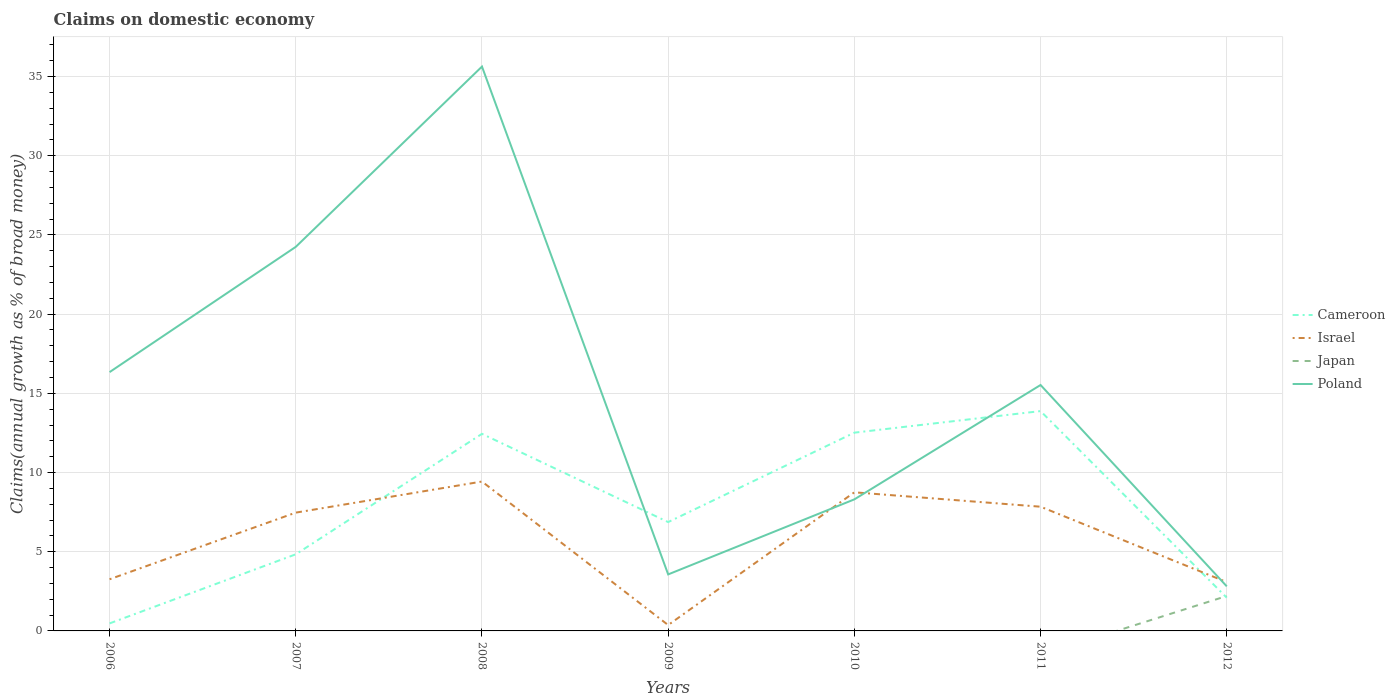How many different coloured lines are there?
Keep it short and to the point. 4. Is the number of lines equal to the number of legend labels?
Your response must be concise. No. Across all years, what is the maximum percentage of broad money claimed on domestic economy in Cameroon?
Keep it short and to the point. 0.47. What is the total percentage of broad money claimed on domestic economy in Cameroon in the graph?
Keep it short and to the point. -4.36. What is the difference between the highest and the second highest percentage of broad money claimed on domestic economy in Poland?
Your answer should be very brief. 32.82. Is the percentage of broad money claimed on domestic economy in Japan strictly greater than the percentage of broad money claimed on domestic economy in Poland over the years?
Your answer should be compact. Yes. Are the values on the major ticks of Y-axis written in scientific E-notation?
Your answer should be compact. No. Where does the legend appear in the graph?
Give a very brief answer. Center right. How many legend labels are there?
Provide a succinct answer. 4. What is the title of the graph?
Ensure brevity in your answer.  Claims on domestic economy. Does "Turks and Caicos Islands" appear as one of the legend labels in the graph?
Your answer should be compact. No. What is the label or title of the Y-axis?
Give a very brief answer. Claims(annual growth as % of broad money). What is the Claims(annual growth as % of broad money) in Cameroon in 2006?
Provide a succinct answer. 0.47. What is the Claims(annual growth as % of broad money) of Israel in 2006?
Make the answer very short. 3.26. What is the Claims(annual growth as % of broad money) in Poland in 2006?
Your answer should be very brief. 16.34. What is the Claims(annual growth as % of broad money) in Cameroon in 2007?
Give a very brief answer. 4.84. What is the Claims(annual growth as % of broad money) of Israel in 2007?
Your answer should be very brief. 7.47. What is the Claims(annual growth as % of broad money) in Japan in 2007?
Offer a terse response. 0. What is the Claims(annual growth as % of broad money) of Poland in 2007?
Make the answer very short. 24.25. What is the Claims(annual growth as % of broad money) of Cameroon in 2008?
Keep it short and to the point. 12.44. What is the Claims(annual growth as % of broad money) in Israel in 2008?
Offer a very short reply. 9.43. What is the Claims(annual growth as % of broad money) of Poland in 2008?
Make the answer very short. 35.63. What is the Claims(annual growth as % of broad money) in Cameroon in 2009?
Your response must be concise. 6.87. What is the Claims(annual growth as % of broad money) of Israel in 2009?
Offer a very short reply. 0.37. What is the Claims(annual growth as % of broad money) of Japan in 2009?
Your response must be concise. 0. What is the Claims(annual growth as % of broad money) of Poland in 2009?
Provide a short and direct response. 3.57. What is the Claims(annual growth as % of broad money) of Cameroon in 2010?
Your response must be concise. 12.52. What is the Claims(annual growth as % of broad money) in Israel in 2010?
Make the answer very short. 8.75. What is the Claims(annual growth as % of broad money) of Japan in 2010?
Give a very brief answer. 0. What is the Claims(annual growth as % of broad money) in Poland in 2010?
Provide a succinct answer. 8.31. What is the Claims(annual growth as % of broad money) in Cameroon in 2011?
Provide a succinct answer. 13.88. What is the Claims(annual growth as % of broad money) of Israel in 2011?
Ensure brevity in your answer.  7.84. What is the Claims(annual growth as % of broad money) of Poland in 2011?
Your answer should be very brief. 15.53. What is the Claims(annual growth as % of broad money) in Cameroon in 2012?
Make the answer very short. 2.1. What is the Claims(annual growth as % of broad money) of Israel in 2012?
Your answer should be compact. 3.08. What is the Claims(annual growth as % of broad money) in Japan in 2012?
Keep it short and to the point. 2.21. What is the Claims(annual growth as % of broad money) of Poland in 2012?
Provide a short and direct response. 2.81. Across all years, what is the maximum Claims(annual growth as % of broad money) in Cameroon?
Your response must be concise. 13.88. Across all years, what is the maximum Claims(annual growth as % of broad money) of Israel?
Provide a short and direct response. 9.43. Across all years, what is the maximum Claims(annual growth as % of broad money) in Japan?
Offer a very short reply. 2.21. Across all years, what is the maximum Claims(annual growth as % of broad money) in Poland?
Make the answer very short. 35.63. Across all years, what is the minimum Claims(annual growth as % of broad money) in Cameroon?
Your answer should be very brief. 0.47. Across all years, what is the minimum Claims(annual growth as % of broad money) of Israel?
Provide a short and direct response. 0.37. Across all years, what is the minimum Claims(annual growth as % of broad money) of Japan?
Your response must be concise. 0. Across all years, what is the minimum Claims(annual growth as % of broad money) of Poland?
Provide a succinct answer. 2.81. What is the total Claims(annual growth as % of broad money) of Cameroon in the graph?
Your answer should be very brief. 53.12. What is the total Claims(annual growth as % of broad money) of Israel in the graph?
Make the answer very short. 40.21. What is the total Claims(annual growth as % of broad money) in Japan in the graph?
Provide a short and direct response. 2.21. What is the total Claims(annual growth as % of broad money) of Poland in the graph?
Ensure brevity in your answer.  106.43. What is the difference between the Claims(annual growth as % of broad money) in Cameroon in 2006 and that in 2007?
Give a very brief answer. -4.36. What is the difference between the Claims(annual growth as % of broad money) in Israel in 2006 and that in 2007?
Offer a very short reply. -4.21. What is the difference between the Claims(annual growth as % of broad money) in Poland in 2006 and that in 2007?
Provide a succinct answer. -7.91. What is the difference between the Claims(annual growth as % of broad money) of Cameroon in 2006 and that in 2008?
Your response must be concise. -11.97. What is the difference between the Claims(annual growth as % of broad money) in Israel in 2006 and that in 2008?
Provide a succinct answer. -6.17. What is the difference between the Claims(annual growth as % of broad money) of Poland in 2006 and that in 2008?
Give a very brief answer. -19.29. What is the difference between the Claims(annual growth as % of broad money) of Cameroon in 2006 and that in 2009?
Keep it short and to the point. -6.4. What is the difference between the Claims(annual growth as % of broad money) of Israel in 2006 and that in 2009?
Your answer should be compact. 2.89. What is the difference between the Claims(annual growth as % of broad money) of Poland in 2006 and that in 2009?
Ensure brevity in your answer.  12.77. What is the difference between the Claims(annual growth as % of broad money) of Cameroon in 2006 and that in 2010?
Your answer should be compact. -12.04. What is the difference between the Claims(annual growth as % of broad money) in Israel in 2006 and that in 2010?
Give a very brief answer. -5.49. What is the difference between the Claims(annual growth as % of broad money) in Poland in 2006 and that in 2010?
Offer a terse response. 8.03. What is the difference between the Claims(annual growth as % of broad money) of Cameroon in 2006 and that in 2011?
Offer a terse response. -13.4. What is the difference between the Claims(annual growth as % of broad money) of Israel in 2006 and that in 2011?
Your answer should be very brief. -4.58. What is the difference between the Claims(annual growth as % of broad money) in Poland in 2006 and that in 2011?
Your answer should be very brief. 0.81. What is the difference between the Claims(annual growth as % of broad money) in Cameroon in 2006 and that in 2012?
Your response must be concise. -1.62. What is the difference between the Claims(annual growth as % of broad money) of Israel in 2006 and that in 2012?
Keep it short and to the point. 0.18. What is the difference between the Claims(annual growth as % of broad money) of Poland in 2006 and that in 2012?
Ensure brevity in your answer.  13.52. What is the difference between the Claims(annual growth as % of broad money) of Cameroon in 2007 and that in 2008?
Provide a succinct answer. -7.6. What is the difference between the Claims(annual growth as % of broad money) of Israel in 2007 and that in 2008?
Your answer should be very brief. -1.96. What is the difference between the Claims(annual growth as % of broad money) in Poland in 2007 and that in 2008?
Make the answer very short. -11.38. What is the difference between the Claims(annual growth as % of broad money) in Cameroon in 2007 and that in 2009?
Make the answer very short. -2.04. What is the difference between the Claims(annual growth as % of broad money) of Israel in 2007 and that in 2009?
Provide a succinct answer. 7.1. What is the difference between the Claims(annual growth as % of broad money) in Poland in 2007 and that in 2009?
Give a very brief answer. 20.68. What is the difference between the Claims(annual growth as % of broad money) of Cameroon in 2007 and that in 2010?
Give a very brief answer. -7.68. What is the difference between the Claims(annual growth as % of broad money) in Israel in 2007 and that in 2010?
Your response must be concise. -1.28. What is the difference between the Claims(annual growth as % of broad money) in Poland in 2007 and that in 2010?
Provide a succinct answer. 15.94. What is the difference between the Claims(annual growth as % of broad money) of Cameroon in 2007 and that in 2011?
Offer a terse response. -9.04. What is the difference between the Claims(annual growth as % of broad money) of Israel in 2007 and that in 2011?
Give a very brief answer. -0.37. What is the difference between the Claims(annual growth as % of broad money) in Poland in 2007 and that in 2011?
Give a very brief answer. 8.72. What is the difference between the Claims(annual growth as % of broad money) in Cameroon in 2007 and that in 2012?
Offer a terse response. 2.74. What is the difference between the Claims(annual growth as % of broad money) in Israel in 2007 and that in 2012?
Make the answer very short. 4.39. What is the difference between the Claims(annual growth as % of broad money) in Poland in 2007 and that in 2012?
Your answer should be very brief. 21.43. What is the difference between the Claims(annual growth as % of broad money) of Cameroon in 2008 and that in 2009?
Provide a succinct answer. 5.57. What is the difference between the Claims(annual growth as % of broad money) in Israel in 2008 and that in 2009?
Make the answer very short. 9.06. What is the difference between the Claims(annual growth as % of broad money) in Poland in 2008 and that in 2009?
Your answer should be very brief. 32.06. What is the difference between the Claims(annual growth as % of broad money) in Cameroon in 2008 and that in 2010?
Your answer should be compact. -0.08. What is the difference between the Claims(annual growth as % of broad money) of Israel in 2008 and that in 2010?
Provide a succinct answer. 0.68. What is the difference between the Claims(annual growth as % of broad money) in Poland in 2008 and that in 2010?
Your answer should be very brief. 27.33. What is the difference between the Claims(annual growth as % of broad money) of Cameroon in 2008 and that in 2011?
Provide a short and direct response. -1.44. What is the difference between the Claims(annual growth as % of broad money) of Israel in 2008 and that in 2011?
Provide a short and direct response. 1.59. What is the difference between the Claims(annual growth as % of broad money) in Poland in 2008 and that in 2011?
Give a very brief answer. 20.1. What is the difference between the Claims(annual growth as % of broad money) of Cameroon in 2008 and that in 2012?
Your answer should be very brief. 10.35. What is the difference between the Claims(annual growth as % of broad money) in Israel in 2008 and that in 2012?
Offer a very short reply. 6.35. What is the difference between the Claims(annual growth as % of broad money) of Poland in 2008 and that in 2012?
Offer a very short reply. 32.82. What is the difference between the Claims(annual growth as % of broad money) in Cameroon in 2009 and that in 2010?
Provide a short and direct response. -5.64. What is the difference between the Claims(annual growth as % of broad money) in Israel in 2009 and that in 2010?
Your answer should be compact. -8.38. What is the difference between the Claims(annual growth as % of broad money) in Poland in 2009 and that in 2010?
Ensure brevity in your answer.  -4.74. What is the difference between the Claims(annual growth as % of broad money) in Cameroon in 2009 and that in 2011?
Provide a short and direct response. -7.01. What is the difference between the Claims(annual growth as % of broad money) in Israel in 2009 and that in 2011?
Your response must be concise. -7.47. What is the difference between the Claims(annual growth as % of broad money) of Poland in 2009 and that in 2011?
Provide a succinct answer. -11.96. What is the difference between the Claims(annual growth as % of broad money) of Cameroon in 2009 and that in 2012?
Ensure brevity in your answer.  4.78. What is the difference between the Claims(annual growth as % of broad money) of Israel in 2009 and that in 2012?
Provide a succinct answer. -2.71. What is the difference between the Claims(annual growth as % of broad money) in Poland in 2009 and that in 2012?
Provide a short and direct response. 0.75. What is the difference between the Claims(annual growth as % of broad money) of Cameroon in 2010 and that in 2011?
Your answer should be very brief. -1.36. What is the difference between the Claims(annual growth as % of broad money) of Israel in 2010 and that in 2011?
Keep it short and to the point. 0.91. What is the difference between the Claims(annual growth as % of broad money) in Poland in 2010 and that in 2011?
Make the answer very short. -7.22. What is the difference between the Claims(annual growth as % of broad money) in Cameroon in 2010 and that in 2012?
Offer a very short reply. 10.42. What is the difference between the Claims(annual growth as % of broad money) in Israel in 2010 and that in 2012?
Offer a very short reply. 5.67. What is the difference between the Claims(annual growth as % of broad money) in Poland in 2010 and that in 2012?
Make the answer very short. 5.49. What is the difference between the Claims(annual growth as % of broad money) in Cameroon in 2011 and that in 2012?
Your answer should be very brief. 11.78. What is the difference between the Claims(annual growth as % of broad money) in Israel in 2011 and that in 2012?
Your response must be concise. 4.76. What is the difference between the Claims(annual growth as % of broad money) in Poland in 2011 and that in 2012?
Give a very brief answer. 12.71. What is the difference between the Claims(annual growth as % of broad money) of Cameroon in 2006 and the Claims(annual growth as % of broad money) of Israel in 2007?
Offer a very short reply. -7. What is the difference between the Claims(annual growth as % of broad money) in Cameroon in 2006 and the Claims(annual growth as % of broad money) in Poland in 2007?
Your answer should be very brief. -23.77. What is the difference between the Claims(annual growth as % of broad money) of Israel in 2006 and the Claims(annual growth as % of broad money) of Poland in 2007?
Your response must be concise. -20.99. What is the difference between the Claims(annual growth as % of broad money) in Cameroon in 2006 and the Claims(annual growth as % of broad money) in Israel in 2008?
Ensure brevity in your answer.  -8.96. What is the difference between the Claims(annual growth as % of broad money) in Cameroon in 2006 and the Claims(annual growth as % of broad money) in Poland in 2008?
Ensure brevity in your answer.  -35.16. What is the difference between the Claims(annual growth as % of broad money) of Israel in 2006 and the Claims(annual growth as % of broad money) of Poland in 2008?
Keep it short and to the point. -32.37. What is the difference between the Claims(annual growth as % of broad money) of Cameroon in 2006 and the Claims(annual growth as % of broad money) of Israel in 2009?
Offer a very short reply. 0.1. What is the difference between the Claims(annual growth as % of broad money) in Cameroon in 2006 and the Claims(annual growth as % of broad money) in Poland in 2009?
Make the answer very short. -3.09. What is the difference between the Claims(annual growth as % of broad money) of Israel in 2006 and the Claims(annual growth as % of broad money) of Poland in 2009?
Keep it short and to the point. -0.31. What is the difference between the Claims(annual growth as % of broad money) in Cameroon in 2006 and the Claims(annual growth as % of broad money) in Israel in 2010?
Your answer should be very brief. -8.28. What is the difference between the Claims(annual growth as % of broad money) of Cameroon in 2006 and the Claims(annual growth as % of broad money) of Poland in 2010?
Provide a succinct answer. -7.83. What is the difference between the Claims(annual growth as % of broad money) of Israel in 2006 and the Claims(annual growth as % of broad money) of Poland in 2010?
Offer a very short reply. -5.04. What is the difference between the Claims(annual growth as % of broad money) of Cameroon in 2006 and the Claims(annual growth as % of broad money) of Israel in 2011?
Provide a succinct answer. -7.37. What is the difference between the Claims(annual growth as % of broad money) in Cameroon in 2006 and the Claims(annual growth as % of broad money) in Poland in 2011?
Ensure brevity in your answer.  -15.05. What is the difference between the Claims(annual growth as % of broad money) in Israel in 2006 and the Claims(annual growth as % of broad money) in Poland in 2011?
Give a very brief answer. -12.27. What is the difference between the Claims(annual growth as % of broad money) in Cameroon in 2006 and the Claims(annual growth as % of broad money) in Israel in 2012?
Offer a very short reply. -2.61. What is the difference between the Claims(annual growth as % of broad money) in Cameroon in 2006 and the Claims(annual growth as % of broad money) in Japan in 2012?
Keep it short and to the point. -1.73. What is the difference between the Claims(annual growth as % of broad money) in Cameroon in 2006 and the Claims(annual growth as % of broad money) in Poland in 2012?
Provide a short and direct response. -2.34. What is the difference between the Claims(annual growth as % of broad money) in Israel in 2006 and the Claims(annual growth as % of broad money) in Japan in 2012?
Provide a short and direct response. 1.06. What is the difference between the Claims(annual growth as % of broad money) of Israel in 2006 and the Claims(annual growth as % of broad money) of Poland in 2012?
Offer a very short reply. 0.45. What is the difference between the Claims(annual growth as % of broad money) of Cameroon in 2007 and the Claims(annual growth as % of broad money) of Israel in 2008?
Offer a very short reply. -4.59. What is the difference between the Claims(annual growth as % of broad money) of Cameroon in 2007 and the Claims(annual growth as % of broad money) of Poland in 2008?
Give a very brief answer. -30.79. What is the difference between the Claims(annual growth as % of broad money) of Israel in 2007 and the Claims(annual growth as % of broad money) of Poland in 2008?
Your response must be concise. -28.16. What is the difference between the Claims(annual growth as % of broad money) in Cameroon in 2007 and the Claims(annual growth as % of broad money) in Israel in 2009?
Offer a very short reply. 4.47. What is the difference between the Claims(annual growth as % of broad money) of Cameroon in 2007 and the Claims(annual growth as % of broad money) of Poland in 2009?
Give a very brief answer. 1.27. What is the difference between the Claims(annual growth as % of broad money) of Israel in 2007 and the Claims(annual growth as % of broad money) of Poland in 2009?
Your response must be concise. 3.9. What is the difference between the Claims(annual growth as % of broad money) of Cameroon in 2007 and the Claims(annual growth as % of broad money) of Israel in 2010?
Offer a terse response. -3.91. What is the difference between the Claims(annual growth as % of broad money) in Cameroon in 2007 and the Claims(annual growth as % of broad money) in Poland in 2010?
Keep it short and to the point. -3.47. What is the difference between the Claims(annual growth as % of broad money) of Israel in 2007 and the Claims(annual growth as % of broad money) of Poland in 2010?
Ensure brevity in your answer.  -0.84. What is the difference between the Claims(annual growth as % of broad money) in Cameroon in 2007 and the Claims(annual growth as % of broad money) in Israel in 2011?
Offer a very short reply. -3. What is the difference between the Claims(annual growth as % of broad money) in Cameroon in 2007 and the Claims(annual growth as % of broad money) in Poland in 2011?
Ensure brevity in your answer.  -10.69. What is the difference between the Claims(annual growth as % of broad money) in Israel in 2007 and the Claims(annual growth as % of broad money) in Poland in 2011?
Offer a terse response. -8.06. What is the difference between the Claims(annual growth as % of broad money) of Cameroon in 2007 and the Claims(annual growth as % of broad money) of Israel in 2012?
Provide a short and direct response. 1.76. What is the difference between the Claims(annual growth as % of broad money) of Cameroon in 2007 and the Claims(annual growth as % of broad money) of Japan in 2012?
Make the answer very short. 2.63. What is the difference between the Claims(annual growth as % of broad money) in Cameroon in 2007 and the Claims(annual growth as % of broad money) in Poland in 2012?
Offer a very short reply. 2.02. What is the difference between the Claims(annual growth as % of broad money) in Israel in 2007 and the Claims(annual growth as % of broad money) in Japan in 2012?
Your answer should be compact. 5.26. What is the difference between the Claims(annual growth as % of broad money) in Israel in 2007 and the Claims(annual growth as % of broad money) in Poland in 2012?
Give a very brief answer. 4.65. What is the difference between the Claims(annual growth as % of broad money) of Cameroon in 2008 and the Claims(annual growth as % of broad money) of Israel in 2009?
Your response must be concise. 12.07. What is the difference between the Claims(annual growth as % of broad money) in Cameroon in 2008 and the Claims(annual growth as % of broad money) in Poland in 2009?
Provide a short and direct response. 8.87. What is the difference between the Claims(annual growth as % of broad money) of Israel in 2008 and the Claims(annual growth as % of broad money) of Poland in 2009?
Offer a very short reply. 5.86. What is the difference between the Claims(annual growth as % of broad money) in Cameroon in 2008 and the Claims(annual growth as % of broad money) in Israel in 2010?
Your answer should be compact. 3.69. What is the difference between the Claims(annual growth as % of broad money) in Cameroon in 2008 and the Claims(annual growth as % of broad money) in Poland in 2010?
Provide a short and direct response. 4.14. What is the difference between the Claims(annual growth as % of broad money) in Israel in 2008 and the Claims(annual growth as % of broad money) in Poland in 2010?
Make the answer very short. 1.13. What is the difference between the Claims(annual growth as % of broad money) of Cameroon in 2008 and the Claims(annual growth as % of broad money) of Israel in 2011?
Make the answer very short. 4.6. What is the difference between the Claims(annual growth as % of broad money) in Cameroon in 2008 and the Claims(annual growth as % of broad money) in Poland in 2011?
Provide a succinct answer. -3.08. What is the difference between the Claims(annual growth as % of broad money) in Israel in 2008 and the Claims(annual growth as % of broad money) in Poland in 2011?
Provide a short and direct response. -6.1. What is the difference between the Claims(annual growth as % of broad money) of Cameroon in 2008 and the Claims(annual growth as % of broad money) of Israel in 2012?
Your answer should be compact. 9.36. What is the difference between the Claims(annual growth as % of broad money) of Cameroon in 2008 and the Claims(annual growth as % of broad money) of Japan in 2012?
Your answer should be very brief. 10.24. What is the difference between the Claims(annual growth as % of broad money) of Cameroon in 2008 and the Claims(annual growth as % of broad money) of Poland in 2012?
Offer a terse response. 9.63. What is the difference between the Claims(annual growth as % of broad money) of Israel in 2008 and the Claims(annual growth as % of broad money) of Japan in 2012?
Ensure brevity in your answer.  7.23. What is the difference between the Claims(annual growth as % of broad money) in Israel in 2008 and the Claims(annual growth as % of broad money) in Poland in 2012?
Provide a succinct answer. 6.62. What is the difference between the Claims(annual growth as % of broad money) in Cameroon in 2009 and the Claims(annual growth as % of broad money) in Israel in 2010?
Provide a short and direct response. -1.88. What is the difference between the Claims(annual growth as % of broad money) of Cameroon in 2009 and the Claims(annual growth as % of broad money) of Poland in 2010?
Provide a short and direct response. -1.43. What is the difference between the Claims(annual growth as % of broad money) in Israel in 2009 and the Claims(annual growth as % of broad money) in Poland in 2010?
Keep it short and to the point. -7.93. What is the difference between the Claims(annual growth as % of broad money) of Cameroon in 2009 and the Claims(annual growth as % of broad money) of Israel in 2011?
Your answer should be very brief. -0.97. What is the difference between the Claims(annual growth as % of broad money) in Cameroon in 2009 and the Claims(annual growth as % of broad money) in Poland in 2011?
Keep it short and to the point. -8.65. What is the difference between the Claims(annual growth as % of broad money) in Israel in 2009 and the Claims(annual growth as % of broad money) in Poland in 2011?
Give a very brief answer. -15.16. What is the difference between the Claims(annual growth as % of broad money) of Cameroon in 2009 and the Claims(annual growth as % of broad money) of Israel in 2012?
Give a very brief answer. 3.79. What is the difference between the Claims(annual growth as % of broad money) in Cameroon in 2009 and the Claims(annual growth as % of broad money) in Japan in 2012?
Provide a short and direct response. 4.67. What is the difference between the Claims(annual growth as % of broad money) in Cameroon in 2009 and the Claims(annual growth as % of broad money) in Poland in 2012?
Give a very brief answer. 4.06. What is the difference between the Claims(annual growth as % of broad money) of Israel in 2009 and the Claims(annual growth as % of broad money) of Japan in 2012?
Provide a succinct answer. -1.83. What is the difference between the Claims(annual growth as % of broad money) of Israel in 2009 and the Claims(annual growth as % of broad money) of Poland in 2012?
Your answer should be compact. -2.44. What is the difference between the Claims(annual growth as % of broad money) of Cameroon in 2010 and the Claims(annual growth as % of broad money) of Israel in 2011?
Offer a very short reply. 4.68. What is the difference between the Claims(annual growth as % of broad money) in Cameroon in 2010 and the Claims(annual growth as % of broad money) in Poland in 2011?
Ensure brevity in your answer.  -3.01. What is the difference between the Claims(annual growth as % of broad money) of Israel in 2010 and the Claims(annual growth as % of broad money) of Poland in 2011?
Ensure brevity in your answer.  -6.78. What is the difference between the Claims(annual growth as % of broad money) in Cameroon in 2010 and the Claims(annual growth as % of broad money) in Israel in 2012?
Your response must be concise. 9.44. What is the difference between the Claims(annual growth as % of broad money) in Cameroon in 2010 and the Claims(annual growth as % of broad money) in Japan in 2012?
Keep it short and to the point. 10.31. What is the difference between the Claims(annual growth as % of broad money) in Cameroon in 2010 and the Claims(annual growth as % of broad money) in Poland in 2012?
Provide a succinct answer. 9.7. What is the difference between the Claims(annual growth as % of broad money) in Israel in 2010 and the Claims(annual growth as % of broad money) in Japan in 2012?
Give a very brief answer. 6.55. What is the difference between the Claims(annual growth as % of broad money) of Israel in 2010 and the Claims(annual growth as % of broad money) of Poland in 2012?
Provide a succinct answer. 5.94. What is the difference between the Claims(annual growth as % of broad money) in Cameroon in 2011 and the Claims(annual growth as % of broad money) in Israel in 2012?
Provide a succinct answer. 10.8. What is the difference between the Claims(annual growth as % of broad money) of Cameroon in 2011 and the Claims(annual growth as % of broad money) of Japan in 2012?
Offer a terse response. 11.67. What is the difference between the Claims(annual growth as % of broad money) in Cameroon in 2011 and the Claims(annual growth as % of broad money) in Poland in 2012?
Offer a very short reply. 11.06. What is the difference between the Claims(annual growth as % of broad money) in Israel in 2011 and the Claims(annual growth as % of broad money) in Japan in 2012?
Keep it short and to the point. 5.64. What is the difference between the Claims(annual growth as % of broad money) in Israel in 2011 and the Claims(annual growth as % of broad money) in Poland in 2012?
Keep it short and to the point. 5.03. What is the average Claims(annual growth as % of broad money) of Cameroon per year?
Your response must be concise. 7.59. What is the average Claims(annual growth as % of broad money) of Israel per year?
Provide a succinct answer. 5.74. What is the average Claims(annual growth as % of broad money) in Japan per year?
Offer a terse response. 0.32. What is the average Claims(annual growth as % of broad money) of Poland per year?
Your response must be concise. 15.2. In the year 2006, what is the difference between the Claims(annual growth as % of broad money) of Cameroon and Claims(annual growth as % of broad money) of Israel?
Offer a terse response. -2.79. In the year 2006, what is the difference between the Claims(annual growth as % of broad money) of Cameroon and Claims(annual growth as % of broad money) of Poland?
Your answer should be compact. -15.86. In the year 2006, what is the difference between the Claims(annual growth as % of broad money) of Israel and Claims(annual growth as % of broad money) of Poland?
Provide a short and direct response. -13.08. In the year 2007, what is the difference between the Claims(annual growth as % of broad money) of Cameroon and Claims(annual growth as % of broad money) of Israel?
Your answer should be very brief. -2.63. In the year 2007, what is the difference between the Claims(annual growth as % of broad money) of Cameroon and Claims(annual growth as % of broad money) of Poland?
Offer a very short reply. -19.41. In the year 2007, what is the difference between the Claims(annual growth as % of broad money) in Israel and Claims(annual growth as % of broad money) in Poland?
Offer a terse response. -16.78. In the year 2008, what is the difference between the Claims(annual growth as % of broad money) in Cameroon and Claims(annual growth as % of broad money) in Israel?
Your answer should be very brief. 3.01. In the year 2008, what is the difference between the Claims(annual growth as % of broad money) in Cameroon and Claims(annual growth as % of broad money) in Poland?
Ensure brevity in your answer.  -23.19. In the year 2008, what is the difference between the Claims(annual growth as % of broad money) of Israel and Claims(annual growth as % of broad money) of Poland?
Keep it short and to the point. -26.2. In the year 2009, what is the difference between the Claims(annual growth as % of broad money) in Cameroon and Claims(annual growth as % of broad money) in Israel?
Your answer should be compact. 6.5. In the year 2009, what is the difference between the Claims(annual growth as % of broad money) of Cameroon and Claims(annual growth as % of broad money) of Poland?
Offer a terse response. 3.3. In the year 2009, what is the difference between the Claims(annual growth as % of broad money) of Israel and Claims(annual growth as % of broad money) of Poland?
Give a very brief answer. -3.2. In the year 2010, what is the difference between the Claims(annual growth as % of broad money) in Cameroon and Claims(annual growth as % of broad money) in Israel?
Offer a terse response. 3.77. In the year 2010, what is the difference between the Claims(annual growth as % of broad money) in Cameroon and Claims(annual growth as % of broad money) in Poland?
Offer a very short reply. 4.21. In the year 2010, what is the difference between the Claims(annual growth as % of broad money) in Israel and Claims(annual growth as % of broad money) in Poland?
Your answer should be compact. 0.45. In the year 2011, what is the difference between the Claims(annual growth as % of broad money) of Cameroon and Claims(annual growth as % of broad money) of Israel?
Your answer should be compact. 6.04. In the year 2011, what is the difference between the Claims(annual growth as % of broad money) in Cameroon and Claims(annual growth as % of broad money) in Poland?
Your answer should be compact. -1.65. In the year 2011, what is the difference between the Claims(annual growth as % of broad money) of Israel and Claims(annual growth as % of broad money) of Poland?
Provide a succinct answer. -7.68. In the year 2012, what is the difference between the Claims(annual growth as % of broad money) of Cameroon and Claims(annual growth as % of broad money) of Israel?
Keep it short and to the point. -0.98. In the year 2012, what is the difference between the Claims(annual growth as % of broad money) in Cameroon and Claims(annual growth as % of broad money) in Japan?
Offer a terse response. -0.11. In the year 2012, what is the difference between the Claims(annual growth as % of broad money) of Cameroon and Claims(annual growth as % of broad money) of Poland?
Your answer should be very brief. -0.72. In the year 2012, what is the difference between the Claims(annual growth as % of broad money) in Israel and Claims(annual growth as % of broad money) in Japan?
Your answer should be compact. 0.88. In the year 2012, what is the difference between the Claims(annual growth as % of broad money) of Israel and Claims(annual growth as % of broad money) of Poland?
Keep it short and to the point. 0.27. In the year 2012, what is the difference between the Claims(annual growth as % of broad money) in Japan and Claims(annual growth as % of broad money) in Poland?
Your answer should be very brief. -0.61. What is the ratio of the Claims(annual growth as % of broad money) in Cameroon in 2006 to that in 2007?
Provide a short and direct response. 0.1. What is the ratio of the Claims(annual growth as % of broad money) in Israel in 2006 to that in 2007?
Give a very brief answer. 0.44. What is the ratio of the Claims(annual growth as % of broad money) of Poland in 2006 to that in 2007?
Provide a succinct answer. 0.67. What is the ratio of the Claims(annual growth as % of broad money) in Cameroon in 2006 to that in 2008?
Your answer should be compact. 0.04. What is the ratio of the Claims(annual growth as % of broad money) in Israel in 2006 to that in 2008?
Ensure brevity in your answer.  0.35. What is the ratio of the Claims(annual growth as % of broad money) in Poland in 2006 to that in 2008?
Provide a succinct answer. 0.46. What is the ratio of the Claims(annual growth as % of broad money) in Cameroon in 2006 to that in 2009?
Your answer should be very brief. 0.07. What is the ratio of the Claims(annual growth as % of broad money) in Israel in 2006 to that in 2009?
Offer a very short reply. 8.79. What is the ratio of the Claims(annual growth as % of broad money) in Poland in 2006 to that in 2009?
Keep it short and to the point. 4.58. What is the ratio of the Claims(annual growth as % of broad money) of Cameroon in 2006 to that in 2010?
Your answer should be very brief. 0.04. What is the ratio of the Claims(annual growth as % of broad money) of Israel in 2006 to that in 2010?
Ensure brevity in your answer.  0.37. What is the ratio of the Claims(annual growth as % of broad money) in Poland in 2006 to that in 2010?
Make the answer very short. 1.97. What is the ratio of the Claims(annual growth as % of broad money) of Cameroon in 2006 to that in 2011?
Your response must be concise. 0.03. What is the ratio of the Claims(annual growth as % of broad money) in Israel in 2006 to that in 2011?
Provide a short and direct response. 0.42. What is the ratio of the Claims(annual growth as % of broad money) of Poland in 2006 to that in 2011?
Offer a terse response. 1.05. What is the ratio of the Claims(annual growth as % of broad money) of Cameroon in 2006 to that in 2012?
Keep it short and to the point. 0.23. What is the ratio of the Claims(annual growth as % of broad money) in Israel in 2006 to that in 2012?
Keep it short and to the point. 1.06. What is the ratio of the Claims(annual growth as % of broad money) of Poland in 2006 to that in 2012?
Your answer should be very brief. 5.81. What is the ratio of the Claims(annual growth as % of broad money) of Cameroon in 2007 to that in 2008?
Give a very brief answer. 0.39. What is the ratio of the Claims(annual growth as % of broad money) in Israel in 2007 to that in 2008?
Offer a terse response. 0.79. What is the ratio of the Claims(annual growth as % of broad money) of Poland in 2007 to that in 2008?
Keep it short and to the point. 0.68. What is the ratio of the Claims(annual growth as % of broad money) in Cameroon in 2007 to that in 2009?
Your answer should be compact. 0.7. What is the ratio of the Claims(annual growth as % of broad money) in Israel in 2007 to that in 2009?
Give a very brief answer. 20.14. What is the ratio of the Claims(annual growth as % of broad money) in Poland in 2007 to that in 2009?
Offer a very short reply. 6.8. What is the ratio of the Claims(annual growth as % of broad money) in Cameroon in 2007 to that in 2010?
Give a very brief answer. 0.39. What is the ratio of the Claims(annual growth as % of broad money) of Israel in 2007 to that in 2010?
Your answer should be compact. 0.85. What is the ratio of the Claims(annual growth as % of broad money) in Poland in 2007 to that in 2010?
Make the answer very short. 2.92. What is the ratio of the Claims(annual growth as % of broad money) of Cameroon in 2007 to that in 2011?
Provide a succinct answer. 0.35. What is the ratio of the Claims(annual growth as % of broad money) in Israel in 2007 to that in 2011?
Your answer should be very brief. 0.95. What is the ratio of the Claims(annual growth as % of broad money) in Poland in 2007 to that in 2011?
Keep it short and to the point. 1.56. What is the ratio of the Claims(annual growth as % of broad money) in Cameroon in 2007 to that in 2012?
Your answer should be compact. 2.31. What is the ratio of the Claims(annual growth as % of broad money) of Israel in 2007 to that in 2012?
Provide a succinct answer. 2.42. What is the ratio of the Claims(annual growth as % of broad money) of Poland in 2007 to that in 2012?
Keep it short and to the point. 8.62. What is the ratio of the Claims(annual growth as % of broad money) in Cameroon in 2008 to that in 2009?
Your answer should be compact. 1.81. What is the ratio of the Claims(annual growth as % of broad money) in Israel in 2008 to that in 2009?
Your response must be concise. 25.43. What is the ratio of the Claims(annual growth as % of broad money) in Poland in 2008 to that in 2009?
Make the answer very short. 9.99. What is the ratio of the Claims(annual growth as % of broad money) in Israel in 2008 to that in 2010?
Your answer should be very brief. 1.08. What is the ratio of the Claims(annual growth as % of broad money) in Poland in 2008 to that in 2010?
Offer a very short reply. 4.29. What is the ratio of the Claims(annual growth as % of broad money) of Cameroon in 2008 to that in 2011?
Keep it short and to the point. 0.9. What is the ratio of the Claims(annual growth as % of broad money) of Israel in 2008 to that in 2011?
Keep it short and to the point. 1.2. What is the ratio of the Claims(annual growth as % of broad money) of Poland in 2008 to that in 2011?
Provide a succinct answer. 2.29. What is the ratio of the Claims(annual growth as % of broad money) of Cameroon in 2008 to that in 2012?
Your answer should be very brief. 5.93. What is the ratio of the Claims(annual growth as % of broad money) in Israel in 2008 to that in 2012?
Offer a terse response. 3.06. What is the ratio of the Claims(annual growth as % of broad money) of Poland in 2008 to that in 2012?
Provide a succinct answer. 12.66. What is the ratio of the Claims(annual growth as % of broad money) in Cameroon in 2009 to that in 2010?
Offer a terse response. 0.55. What is the ratio of the Claims(annual growth as % of broad money) of Israel in 2009 to that in 2010?
Provide a short and direct response. 0.04. What is the ratio of the Claims(annual growth as % of broad money) in Poland in 2009 to that in 2010?
Offer a terse response. 0.43. What is the ratio of the Claims(annual growth as % of broad money) of Cameroon in 2009 to that in 2011?
Offer a terse response. 0.5. What is the ratio of the Claims(annual growth as % of broad money) in Israel in 2009 to that in 2011?
Provide a short and direct response. 0.05. What is the ratio of the Claims(annual growth as % of broad money) of Poland in 2009 to that in 2011?
Your answer should be very brief. 0.23. What is the ratio of the Claims(annual growth as % of broad money) in Cameroon in 2009 to that in 2012?
Your response must be concise. 3.28. What is the ratio of the Claims(annual growth as % of broad money) in Israel in 2009 to that in 2012?
Ensure brevity in your answer.  0.12. What is the ratio of the Claims(annual growth as % of broad money) in Poland in 2009 to that in 2012?
Make the answer very short. 1.27. What is the ratio of the Claims(annual growth as % of broad money) in Cameroon in 2010 to that in 2011?
Make the answer very short. 0.9. What is the ratio of the Claims(annual growth as % of broad money) of Israel in 2010 to that in 2011?
Make the answer very short. 1.12. What is the ratio of the Claims(annual growth as % of broad money) of Poland in 2010 to that in 2011?
Give a very brief answer. 0.53. What is the ratio of the Claims(annual growth as % of broad money) of Cameroon in 2010 to that in 2012?
Keep it short and to the point. 5.97. What is the ratio of the Claims(annual growth as % of broad money) of Israel in 2010 to that in 2012?
Keep it short and to the point. 2.84. What is the ratio of the Claims(annual growth as % of broad money) in Poland in 2010 to that in 2012?
Ensure brevity in your answer.  2.95. What is the ratio of the Claims(annual growth as % of broad money) in Cameroon in 2011 to that in 2012?
Provide a short and direct response. 6.62. What is the ratio of the Claims(annual growth as % of broad money) in Israel in 2011 to that in 2012?
Offer a terse response. 2.54. What is the ratio of the Claims(annual growth as % of broad money) of Poland in 2011 to that in 2012?
Offer a very short reply. 5.52. What is the difference between the highest and the second highest Claims(annual growth as % of broad money) of Cameroon?
Provide a succinct answer. 1.36. What is the difference between the highest and the second highest Claims(annual growth as % of broad money) of Israel?
Provide a short and direct response. 0.68. What is the difference between the highest and the second highest Claims(annual growth as % of broad money) in Poland?
Your response must be concise. 11.38. What is the difference between the highest and the lowest Claims(annual growth as % of broad money) of Cameroon?
Your response must be concise. 13.4. What is the difference between the highest and the lowest Claims(annual growth as % of broad money) in Israel?
Provide a succinct answer. 9.06. What is the difference between the highest and the lowest Claims(annual growth as % of broad money) of Japan?
Offer a very short reply. 2.21. What is the difference between the highest and the lowest Claims(annual growth as % of broad money) of Poland?
Provide a succinct answer. 32.82. 